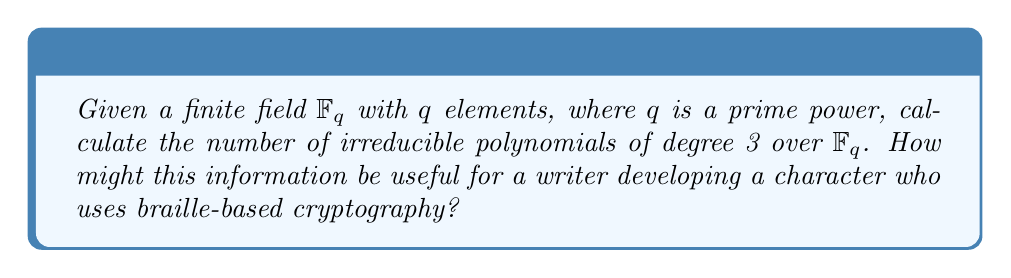Can you answer this question? To calculate the number of irreducible polynomials of degree 3 over $\mathbb{F}_q$, we can use the following steps:

1) First, recall the formula for the number of monic irreducible polynomials of degree $n$ over $\mathbb{F}_q$:

   $$I_n = \frac{1}{n} \sum_{d|n} \mu(d)q^{n/d}$$

   where $\mu(d)$ is the Möbius function and the sum is over all positive divisors $d$ of $n$.

2) In our case, $n = 3$. The divisors of 3 are 1 and 3.

3) Calculate the Möbius function values:
   $\mu(1) = 1$
   $\mu(3) = -1$

4) Substitute into the formula:

   $$I_3 = \frac{1}{3} (\mu(1)q^{3/1} + \mu(3)q^{3/3})$$

5) Simplify:

   $$I_3 = \frac{1}{3} (q^3 - q)$$

6) This gives us the final formula for the number of irreducible polynomials of degree 3 over $\mathbb{F}_q$.

For a writer developing a character who uses braille-based cryptography, this information could be valuable in creating a secure encryption system. Irreducible polynomials are often used in cryptography because they generate maximal length sequences, which have good randomness properties. A character could use the number of irreducible polynomials to determine the key space for their encryption system, or to create a unique mapping between braille characters and polynomial coefficients.
Answer: $\frac{1}{3}(q^3 - q)$ 